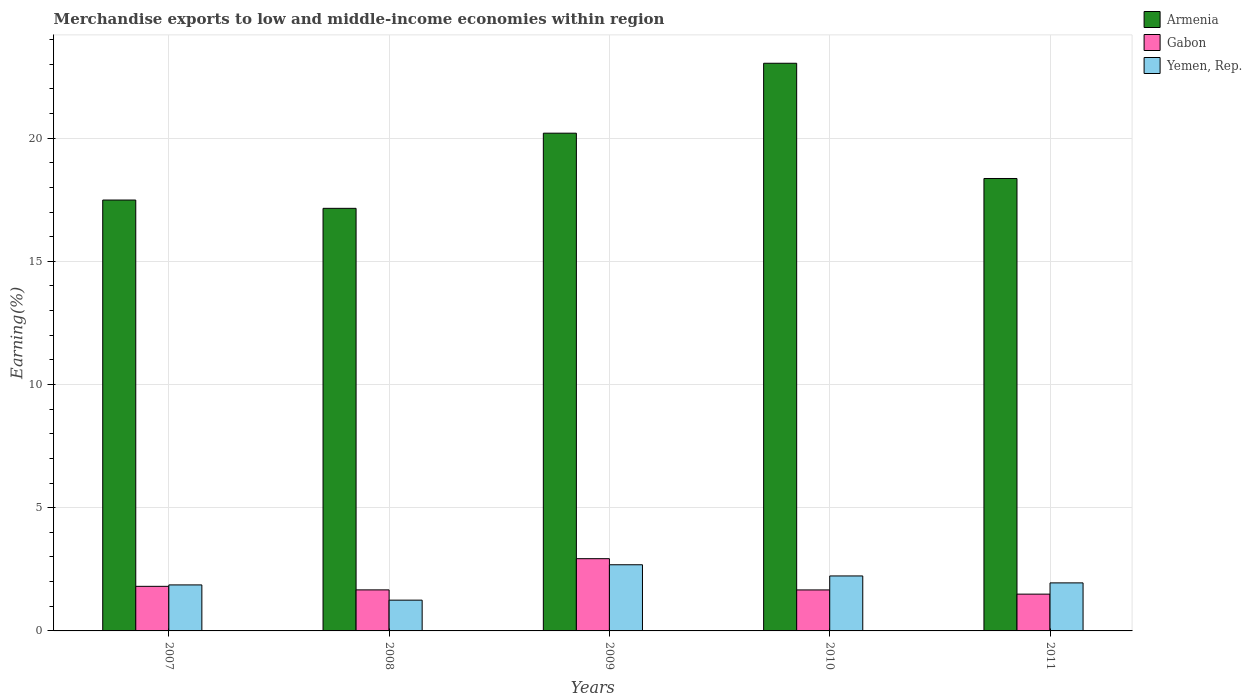How many different coloured bars are there?
Give a very brief answer. 3. How many groups of bars are there?
Your answer should be compact. 5. What is the label of the 2nd group of bars from the left?
Give a very brief answer. 2008. In how many cases, is the number of bars for a given year not equal to the number of legend labels?
Make the answer very short. 0. What is the percentage of amount earned from merchandise exports in Armenia in 2007?
Ensure brevity in your answer.  17.49. Across all years, what is the maximum percentage of amount earned from merchandise exports in Yemen, Rep.?
Make the answer very short. 2.69. Across all years, what is the minimum percentage of amount earned from merchandise exports in Armenia?
Offer a terse response. 17.15. What is the total percentage of amount earned from merchandise exports in Gabon in the graph?
Keep it short and to the point. 9.56. What is the difference between the percentage of amount earned from merchandise exports in Armenia in 2007 and that in 2010?
Your response must be concise. -5.55. What is the difference between the percentage of amount earned from merchandise exports in Gabon in 2011 and the percentage of amount earned from merchandise exports in Yemen, Rep. in 2009?
Keep it short and to the point. -1.19. What is the average percentage of amount earned from merchandise exports in Gabon per year?
Offer a very short reply. 1.91. In the year 2011, what is the difference between the percentage of amount earned from merchandise exports in Yemen, Rep. and percentage of amount earned from merchandise exports in Armenia?
Make the answer very short. -16.41. In how many years, is the percentage of amount earned from merchandise exports in Gabon greater than 22 %?
Make the answer very short. 0. What is the ratio of the percentage of amount earned from merchandise exports in Yemen, Rep. in 2009 to that in 2011?
Make the answer very short. 1.38. Is the percentage of amount earned from merchandise exports in Yemen, Rep. in 2010 less than that in 2011?
Your answer should be very brief. No. What is the difference between the highest and the second highest percentage of amount earned from merchandise exports in Yemen, Rep.?
Give a very brief answer. 0.45. What is the difference between the highest and the lowest percentage of amount earned from merchandise exports in Armenia?
Your answer should be compact. 5.89. In how many years, is the percentage of amount earned from merchandise exports in Armenia greater than the average percentage of amount earned from merchandise exports in Armenia taken over all years?
Your response must be concise. 2. What does the 1st bar from the left in 2010 represents?
Ensure brevity in your answer.  Armenia. What does the 1st bar from the right in 2007 represents?
Your answer should be very brief. Yemen, Rep. Is it the case that in every year, the sum of the percentage of amount earned from merchandise exports in Armenia and percentage of amount earned from merchandise exports in Yemen, Rep. is greater than the percentage of amount earned from merchandise exports in Gabon?
Offer a terse response. Yes. How many bars are there?
Your answer should be very brief. 15. What is the difference between two consecutive major ticks on the Y-axis?
Give a very brief answer. 5. What is the title of the graph?
Make the answer very short. Merchandise exports to low and middle-income economies within region. What is the label or title of the X-axis?
Keep it short and to the point. Years. What is the label or title of the Y-axis?
Your answer should be compact. Earning(%). What is the Earning(%) in Armenia in 2007?
Offer a terse response. 17.49. What is the Earning(%) in Gabon in 2007?
Provide a short and direct response. 1.81. What is the Earning(%) of Yemen, Rep. in 2007?
Provide a succinct answer. 1.87. What is the Earning(%) in Armenia in 2008?
Your answer should be compact. 17.15. What is the Earning(%) of Gabon in 2008?
Offer a terse response. 1.67. What is the Earning(%) in Yemen, Rep. in 2008?
Make the answer very short. 1.25. What is the Earning(%) of Armenia in 2009?
Provide a succinct answer. 20.2. What is the Earning(%) in Gabon in 2009?
Your answer should be very brief. 2.93. What is the Earning(%) of Yemen, Rep. in 2009?
Your answer should be very brief. 2.69. What is the Earning(%) of Armenia in 2010?
Offer a terse response. 23.04. What is the Earning(%) in Gabon in 2010?
Your answer should be compact. 1.66. What is the Earning(%) in Yemen, Rep. in 2010?
Your response must be concise. 2.23. What is the Earning(%) of Armenia in 2011?
Your response must be concise. 18.36. What is the Earning(%) in Gabon in 2011?
Keep it short and to the point. 1.49. What is the Earning(%) in Yemen, Rep. in 2011?
Offer a terse response. 1.95. Across all years, what is the maximum Earning(%) in Armenia?
Your answer should be very brief. 23.04. Across all years, what is the maximum Earning(%) in Gabon?
Provide a short and direct response. 2.93. Across all years, what is the maximum Earning(%) of Yemen, Rep.?
Ensure brevity in your answer.  2.69. Across all years, what is the minimum Earning(%) in Armenia?
Make the answer very short. 17.15. Across all years, what is the minimum Earning(%) in Gabon?
Offer a terse response. 1.49. Across all years, what is the minimum Earning(%) in Yemen, Rep.?
Give a very brief answer. 1.25. What is the total Earning(%) in Armenia in the graph?
Your answer should be compact. 96.23. What is the total Earning(%) of Gabon in the graph?
Give a very brief answer. 9.56. What is the total Earning(%) in Yemen, Rep. in the graph?
Provide a short and direct response. 9.98. What is the difference between the Earning(%) of Armenia in 2007 and that in 2008?
Offer a very short reply. 0.34. What is the difference between the Earning(%) of Gabon in 2007 and that in 2008?
Give a very brief answer. 0.14. What is the difference between the Earning(%) of Yemen, Rep. in 2007 and that in 2008?
Your answer should be compact. 0.62. What is the difference between the Earning(%) in Armenia in 2007 and that in 2009?
Offer a very short reply. -2.71. What is the difference between the Earning(%) of Gabon in 2007 and that in 2009?
Your response must be concise. -1.12. What is the difference between the Earning(%) of Yemen, Rep. in 2007 and that in 2009?
Your answer should be compact. -0.82. What is the difference between the Earning(%) in Armenia in 2007 and that in 2010?
Give a very brief answer. -5.55. What is the difference between the Earning(%) of Gabon in 2007 and that in 2010?
Your response must be concise. 0.15. What is the difference between the Earning(%) in Yemen, Rep. in 2007 and that in 2010?
Make the answer very short. -0.36. What is the difference between the Earning(%) in Armenia in 2007 and that in 2011?
Offer a terse response. -0.87. What is the difference between the Earning(%) of Gabon in 2007 and that in 2011?
Provide a short and direct response. 0.32. What is the difference between the Earning(%) of Yemen, Rep. in 2007 and that in 2011?
Keep it short and to the point. -0.08. What is the difference between the Earning(%) of Armenia in 2008 and that in 2009?
Provide a succinct answer. -3.05. What is the difference between the Earning(%) of Gabon in 2008 and that in 2009?
Provide a succinct answer. -1.27. What is the difference between the Earning(%) in Yemen, Rep. in 2008 and that in 2009?
Your answer should be very brief. -1.44. What is the difference between the Earning(%) in Armenia in 2008 and that in 2010?
Keep it short and to the point. -5.89. What is the difference between the Earning(%) of Gabon in 2008 and that in 2010?
Ensure brevity in your answer.  0. What is the difference between the Earning(%) in Yemen, Rep. in 2008 and that in 2010?
Provide a short and direct response. -0.98. What is the difference between the Earning(%) of Armenia in 2008 and that in 2011?
Give a very brief answer. -1.21. What is the difference between the Earning(%) in Gabon in 2008 and that in 2011?
Provide a succinct answer. 0.17. What is the difference between the Earning(%) in Yemen, Rep. in 2008 and that in 2011?
Give a very brief answer. -0.7. What is the difference between the Earning(%) in Armenia in 2009 and that in 2010?
Ensure brevity in your answer.  -2.84. What is the difference between the Earning(%) of Gabon in 2009 and that in 2010?
Offer a terse response. 1.27. What is the difference between the Earning(%) in Yemen, Rep. in 2009 and that in 2010?
Keep it short and to the point. 0.45. What is the difference between the Earning(%) of Armenia in 2009 and that in 2011?
Make the answer very short. 1.84. What is the difference between the Earning(%) in Gabon in 2009 and that in 2011?
Make the answer very short. 1.44. What is the difference between the Earning(%) of Yemen, Rep. in 2009 and that in 2011?
Your answer should be very brief. 0.74. What is the difference between the Earning(%) in Armenia in 2010 and that in 2011?
Give a very brief answer. 4.68. What is the difference between the Earning(%) of Gabon in 2010 and that in 2011?
Provide a short and direct response. 0.17. What is the difference between the Earning(%) of Yemen, Rep. in 2010 and that in 2011?
Your answer should be compact. 0.28. What is the difference between the Earning(%) in Armenia in 2007 and the Earning(%) in Gabon in 2008?
Your response must be concise. 15.82. What is the difference between the Earning(%) in Armenia in 2007 and the Earning(%) in Yemen, Rep. in 2008?
Provide a short and direct response. 16.24. What is the difference between the Earning(%) in Gabon in 2007 and the Earning(%) in Yemen, Rep. in 2008?
Provide a short and direct response. 0.56. What is the difference between the Earning(%) of Armenia in 2007 and the Earning(%) of Gabon in 2009?
Provide a succinct answer. 14.55. What is the difference between the Earning(%) of Armenia in 2007 and the Earning(%) of Yemen, Rep. in 2009?
Provide a succinct answer. 14.8. What is the difference between the Earning(%) of Gabon in 2007 and the Earning(%) of Yemen, Rep. in 2009?
Your response must be concise. -0.88. What is the difference between the Earning(%) in Armenia in 2007 and the Earning(%) in Gabon in 2010?
Provide a short and direct response. 15.82. What is the difference between the Earning(%) in Armenia in 2007 and the Earning(%) in Yemen, Rep. in 2010?
Provide a short and direct response. 15.26. What is the difference between the Earning(%) of Gabon in 2007 and the Earning(%) of Yemen, Rep. in 2010?
Your answer should be compact. -0.42. What is the difference between the Earning(%) of Armenia in 2007 and the Earning(%) of Gabon in 2011?
Offer a terse response. 15.99. What is the difference between the Earning(%) in Armenia in 2007 and the Earning(%) in Yemen, Rep. in 2011?
Keep it short and to the point. 15.54. What is the difference between the Earning(%) in Gabon in 2007 and the Earning(%) in Yemen, Rep. in 2011?
Offer a terse response. -0.14. What is the difference between the Earning(%) in Armenia in 2008 and the Earning(%) in Gabon in 2009?
Ensure brevity in your answer.  14.22. What is the difference between the Earning(%) in Armenia in 2008 and the Earning(%) in Yemen, Rep. in 2009?
Offer a terse response. 14.46. What is the difference between the Earning(%) in Gabon in 2008 and the Earning(%) in Yemen, Rep. in 2009?
Ensure brevity in your answer.  -1.02. What is the difference between the Earning(%) in Armenia in 2008 and the Earning(%) in Gabon in 2010?
Provide a short and direct response. 15.49. What is the difference between the Earning(%) in Armenia in 2008 and the Earning(%) in Yemen, Rep. in 2010?
Your response must be concise. 14.92. What is the difference between the Earning(%) in Gabon in 2008 and the Earning(%) in Yemen, Rep. in 2010?
Provide a succinct answer. -0.57. What is the difference between the Earning(%) in Armenia in 2008 and the Earning(%) in Gabon in 2011?
Your response must be concise. 15.66. What is the difference between the Earning(%) of Armenia in 2008 and the Earning(%) of Yemen, Rep. in 2011?
Your answer should be very brief. 15.2. What is the difference between the Earning(%) in Gabon in 2008 and the Earning(%) in Yemen, Rep. in 2011?
Your answer should be compact. -0.28. What is the difference between the Earning(%) of Armenia in 2009 and the Earning(%) of Gabon in 2010?
Offer a very short reply. 18.54. What is the difference between the Earning(%) of Armenia in 2009 and the Earning(%) of Yemen, Rep. in 2010?
Provide a succinct answer. 17.97. What is the difference between the Earning(%) in Gabon in 2009 and the Earning(%) in Yemen, Rep. in 2010?
Offer a terse response. 0.7. What is the difference between the Earning(%) in Armenia in 2009 and the Earning(%) in Gabon in 2011?
Provide a short and direct response. 18.71. What is the difference between the Earning(%) in Armenia in 2009 and the Earning(%) in Yemen, Rep. in 2011?
Offer a terse response. 18.25. What is the difference between the Earning(%) in Gabon in 2009 and the Earning(%) in Yemen, Rep. in 2011?
Offer a very short reply. 0.98. What is the difference between the Earning(%) in Armenia in 2010 and the Earning(%) in Gabon in 2011?
Your answer should be compact. 21.54. What is the difference between the Earning(%) in Armenia in 2010 and the Earning(%) in Yemen, Rep. in 2011?
Your answer should be very brief. 21.09. What is the difference between the Earning(%) in Gabon in 2010 and the Earning(%) in Yemen, Rep. in 2011?
Your response must be concise. -0.29. What is the average Earning(%) in Armenia per year?
Ensure brevity in your answer.  19.25. What is the average Earning(%) in Gabon per year?
Provide a succinct answer. 1.91. What is the average Earning(%) of Yemen, Rep. per year?
Keep it short and to the point. 2. In the year 2007, what is the difference between the Earning(%) in Armenia and Earning(%) in Gabon?
Your answer should be compact. 15.68. In the year 2007, what is the difference between the Earning(%) in Armenia and Earning(%) in Yemen, Rep.?
Keep it short and to the point. 15.62. In the year 2007, what is the difference between the Earning(%) in Gabon and Earning(%) in Yemen, Rep.?
Provide a succinct answer. -0.06. In the year 2008, what is the difference between the Earning(%) in Armenia and Earning(%) in Gabon?
Provide a short and direct response. 15.48. In the year 2008, what is the difference between the Earning(%) of Armenia and Earning(%) of Yemen, Rep.?
Offer a terse response. 15.9. In the year 2008, what is the difference between the Earning(%) of Gabon and Earning(%) of Yemen, Rep.?
Offer a very short reply. 0.42. In the year 2009, what is the difference between the Earning(%) of Armenia and Earning(%) of Gabon?
Make the answer very short. 17.27. In the year 2009, what is the difference between the Earning(%) of Armenia and Earning(%) of Yemen, Rep.?
Keep it short and to the point. 17.51. In the year 2009, what is the difference between the Earning(%) in Gabon and Earning(%) in Yemen, Rep.?
Provide a short and direct response. 0.25. In the year 2010, what is the difference between the Earning(%) of Armenia and Earning(%) of Gabon?
Your answer should be very brief. 21.37. In the year 2010, what is the difference between the Earning(%) in Armenia and Earning(%) in Yemen, Rep.?
Provide a succinct answer. 20.81. In the year 2010, what is the difference between the Earning(%) in Gabon and Earning(%) in Yemen, Rep.?
Offer a terse response. -0.57. In the year 2011, what is the difference between the Earning(%) of Armenia and Earning(%) of Gabon?
Your answer should be very brief. 16.87. In the year 2011, what is the difference between the Earning(%) in Armenia and Earning(%) in Yemen, Rep.?
Provide a succinct answer. 16.41. In the year 2011, what is the difference between the Earning(%) in Gabon and Earning(%) in Yemen, Rep.?
Ensure brevity in your answer.  -0.46. What is the ratio of the Earning(%) in Armenia in 2007 to that in 2008?
Your answer should be compact. 1.02. What is the ratio of the Earning(%) of Gabon in 2007 to that in 2008?
Offer a terse response. 1.09. What is the ratio of the Earning(%) in Yemen, Rep. in 2007 to that in 2008?
Keep it short and to the point. 1.5. What is the ratio of the Earning(%) of Armenia in 2007 to that in 2009?
Your answer should be compact. 0.87. What is the ratio of the Earning(%) in Gabon in 2007 to that in 2009?
Ensure brevity in your answer.  0.62. What is the ratio of the Earning(%) of Yemen, Rep. in 2007 to that in 2009?
Make the answer very short. 0.7. What is the ratio of the Earning(%) in Armenia in 2007 to that in 2010?
Your response must be concise. 0.76. What is the ratio of the Earning(%) in Gabon in 2007 to that in 2010?
Your answer should be compact. 1.09. What is the ratio of the Earning(%) of Yemen, Rep. in 2007 to that in 2010?
Your response must be concise. 0.84. What is the ratio of the Earning(%) in Armenia in 2007 to that in 2011?
Ensure brevity in your answer.  0.95. What is the ratio of the Earning(%) of Gabon in 2007 to that in 2011?
Give a very brief answer. 1.21. What is the ratio of the Earning(%) of Yemen, Rep. in 2007 to that in 2011?
Your response must be concise. 0.96. What is the ratio of the Earning(%) in Armenia in 2008 to that in 2009?
Make the answer very short. 0.85. What is the ratio of the Earning(%) in Gabon in 2008 to that in 2009?
Offer a very short reply. 0.57. What is the ratio of the Earning(%) in Yemen, Rep. in 2008 to that in 2009?
Your answer should be very brief. 0.47. What is the ratio of the Earning(%) in Armenia in 2008 to that in 2010?
Give a very brief answer. 0.74. What is the ratio of the Earning(%) of Yemen, Rep. in 2008 to that in 2010?
Make the answer very short. 0.56. What is the ratio of the Earning(%) in Armenia in 2008 to that in 2011?
Your answer should be compact. 0.93. What is the ratio of the Earning(%) in Gabon in 2008 to that in 2011?
Ensure brevity in your answer.  1.12. What is the ratio of the Earning(%) of Yemen, Rep. in 2008 to that in 2011?
Ensure brevity in your answer.  0.64. What is the ratio of the Earning(%) in Armenia in 2009 to that in 2010?
Keep it short and to the point. 0.88. What is the ratio of the Earning(%) of Gabon in 2009 to that in 2010?
Your response must be concise. 1.76. What is the ratio of the Earning(%) in Yemen, Rep. in 2009 to that in 2010?
Give a very brief answer. 1.2. What is the ratio of the Earning(%) in Armenia in 2009 to that in 2011?
Keep it short and to the point. 1.1. What is the ratio of the Earning(%) in Gabon in 2009 to that in 2011?
Keep it short and to the point. 1.96. What is the ratio of the Earning(%) of Yemen, Rep. in 2009 to that in 2011?
Your answer should be very brief. 1.38. What is the ratio of the Earning(%) of Armenia in 2010 to that in 2011?
Make the answer very short. 1.25. What is the ratio of the Earning(%) of Gabon in 2010 to that in 2011?
Provide a short and direct response. 1.11. What is the ratio of the Earning(%) of Yemen, Rep. in 2010 to that in 2011?
Your answer should be very brief. 1.14. What is the difference between the highest and the second highest Earning(%) in Armenia?
Your answer should be very brief. 2.84. What is the difference between the highest and the second highest Earning(%) in Gabon?
Offer a very short reply. 1.12. What is the difference between the highest and the second highest Earning(%) of Yemen, Rep.?
Offer a terse response. 0.45. What is the difference between the highest and the lowest Earning(%) in Armenia?
Provide a succinct answer. 5.89. What is the difference between the highest and the lowest Earning(%) in Gabon?
Provide a short and direct response. 1.44. What is the difference between the highest and the lowest Earning(%) of Yemen, Rep.?
Make the answer very short. 1.44. 